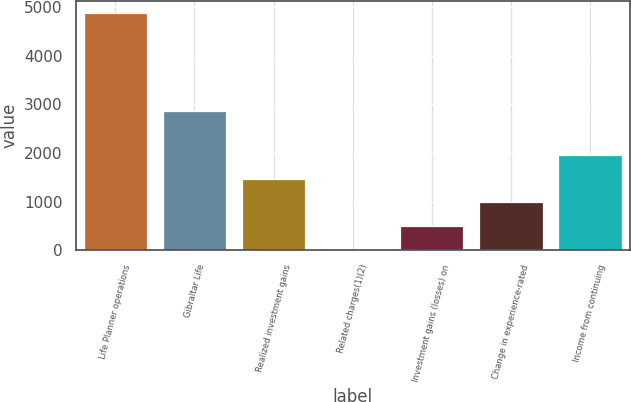<chart> <loc_0><loc_0><loc_500><loc_500><bar_chart><fcel>Life Planner operations<fcel>Gibraltar Life<fcel>Realized investment gains<fcel>Related charges(1)(2)<fcel>Investment gains (losses) on<fcel>Change in experience-rated<fcel>Income from continuing<nl><fcel>4876<fcel>2854<fcel>1470.5<fcel>11<fcel>497.5<fcel>984<fcel>1957<nl></chart> 